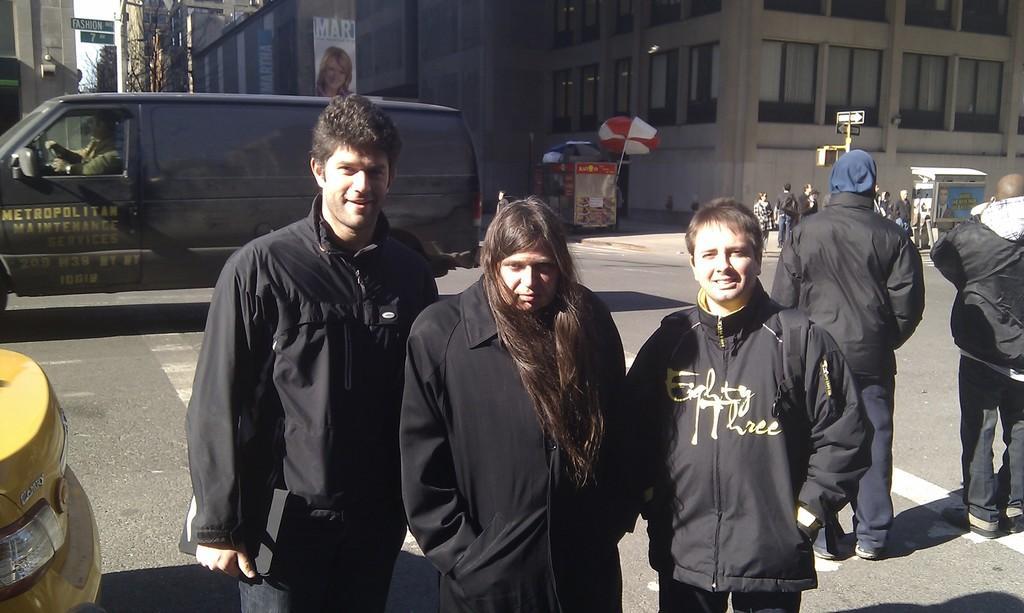Could you give a brief overview of what you see in this image? In this image, I can see few people standing. This looks like a van. Here is a person sitting in the van. These are the buildings with the windows. I think this is an umbrella. This looks like a hoarding. I can see a group of people standing. These are the poles attached to a pole. On the right side of the image, I think this is a car. 